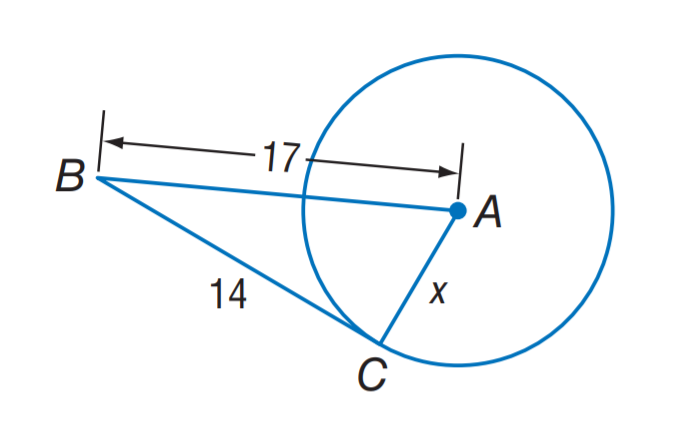Question: Assume that the segment is tangent, find the value of x.
Choices:
A. \sqrt { 14 }
B. \sqrt { 17 }
C. \sqrt { 93 }
D. \sqrt { 485 }
Answer with the letter. Answer: C 